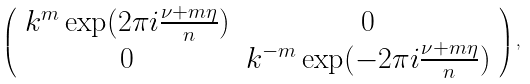<formula> <loc_0><loc_0><loc_500><loc_500>\left ( \begin{array} { c c } k ^ { m } \exp ( 2 \pi i \frac { \nu + m \eta } n ) & 0 \\ 0 & k ^ { - m } \exp ( - 2 \pi i \frac { \nu + m \eta } n ) \end{array} \right ) ,</formula> 